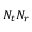Convert formula to latex. <formula><loc_0><loc_0><loc_500><loc_500>N _ { t } N _ { r }</formula> 